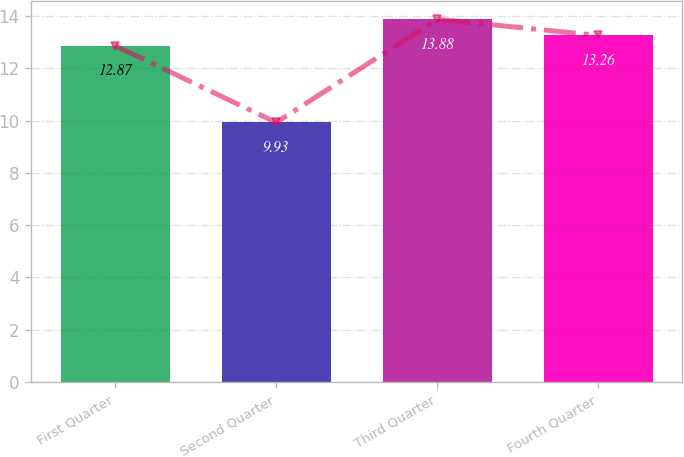Convert chart. <chart><loc_0><loc_0><loc_500><loc_500><bar_chart><fcel>First Quarter<fcel>Second Quarter<fcel>Third Quarter<fcel>Fourth Quarter<nl><fcel>12.87<fcel>9.93<fcel>13.88<fcel>13.26<nl></chart> 